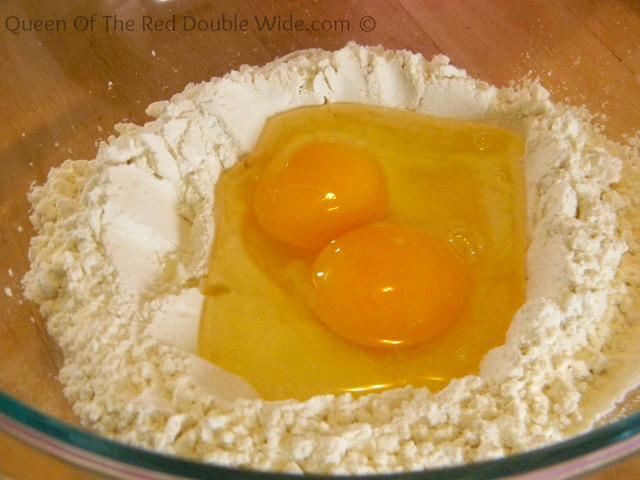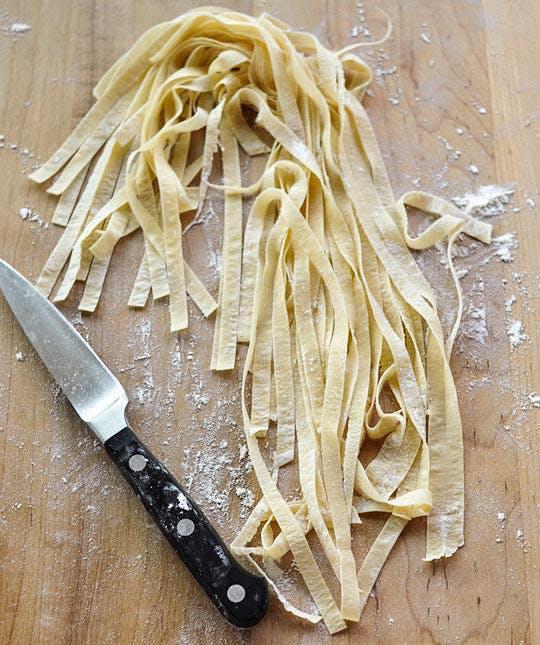The first image is the image on the left, the second image is the image on the right. Evaluate the accuracy of this statement regarding the images: "One photo shows clearly visible eggs being used as an ingredient and the other image shows completed homemade noodles.". Is it true? Answer yes or no. Yes. 